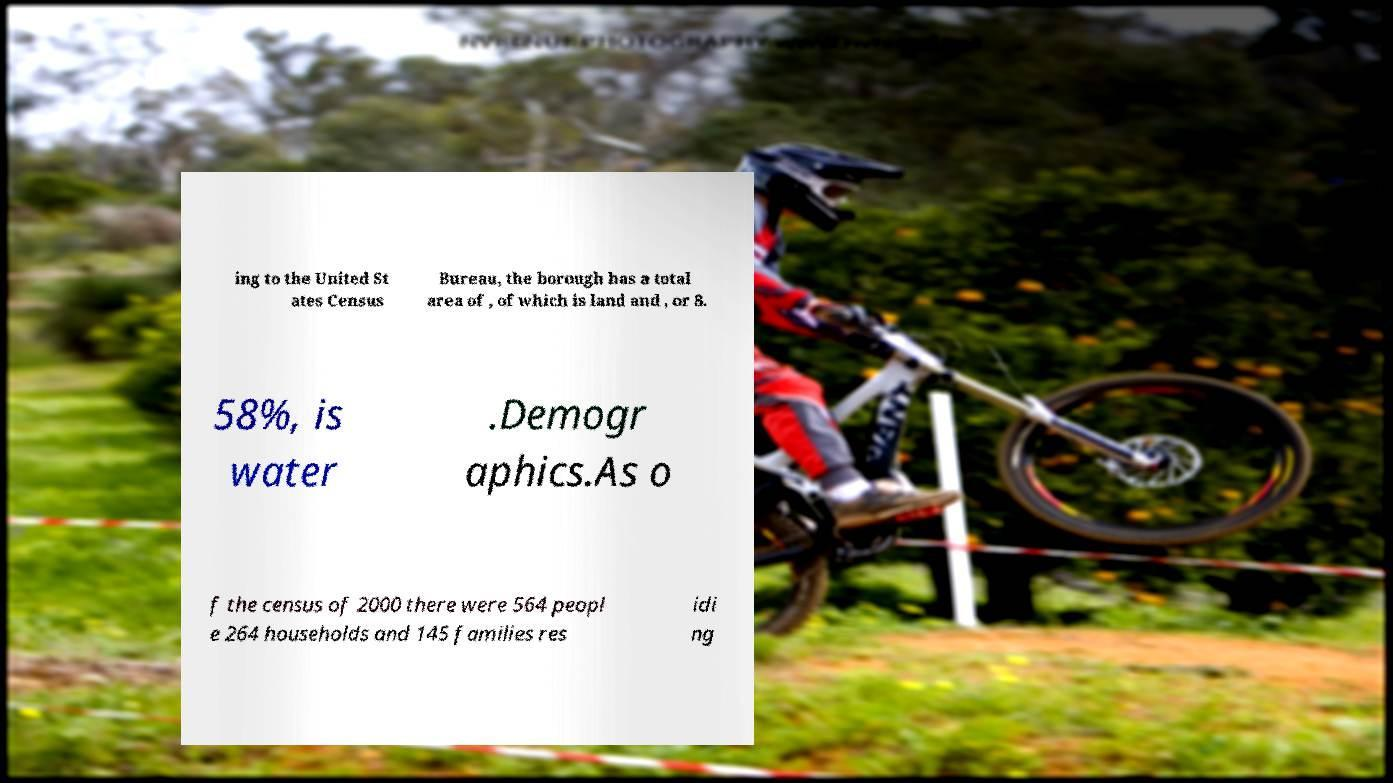Could you assist in decoding the text presented in this image and type it out clearly? ing to the United St ates Census Bureau, the borough has a total area of , of which is land and , or 8. 58%, is water .Demogr aphics.As o f the census of 2000 there were 564 peopl e 264 households and 145 families res idi ng 